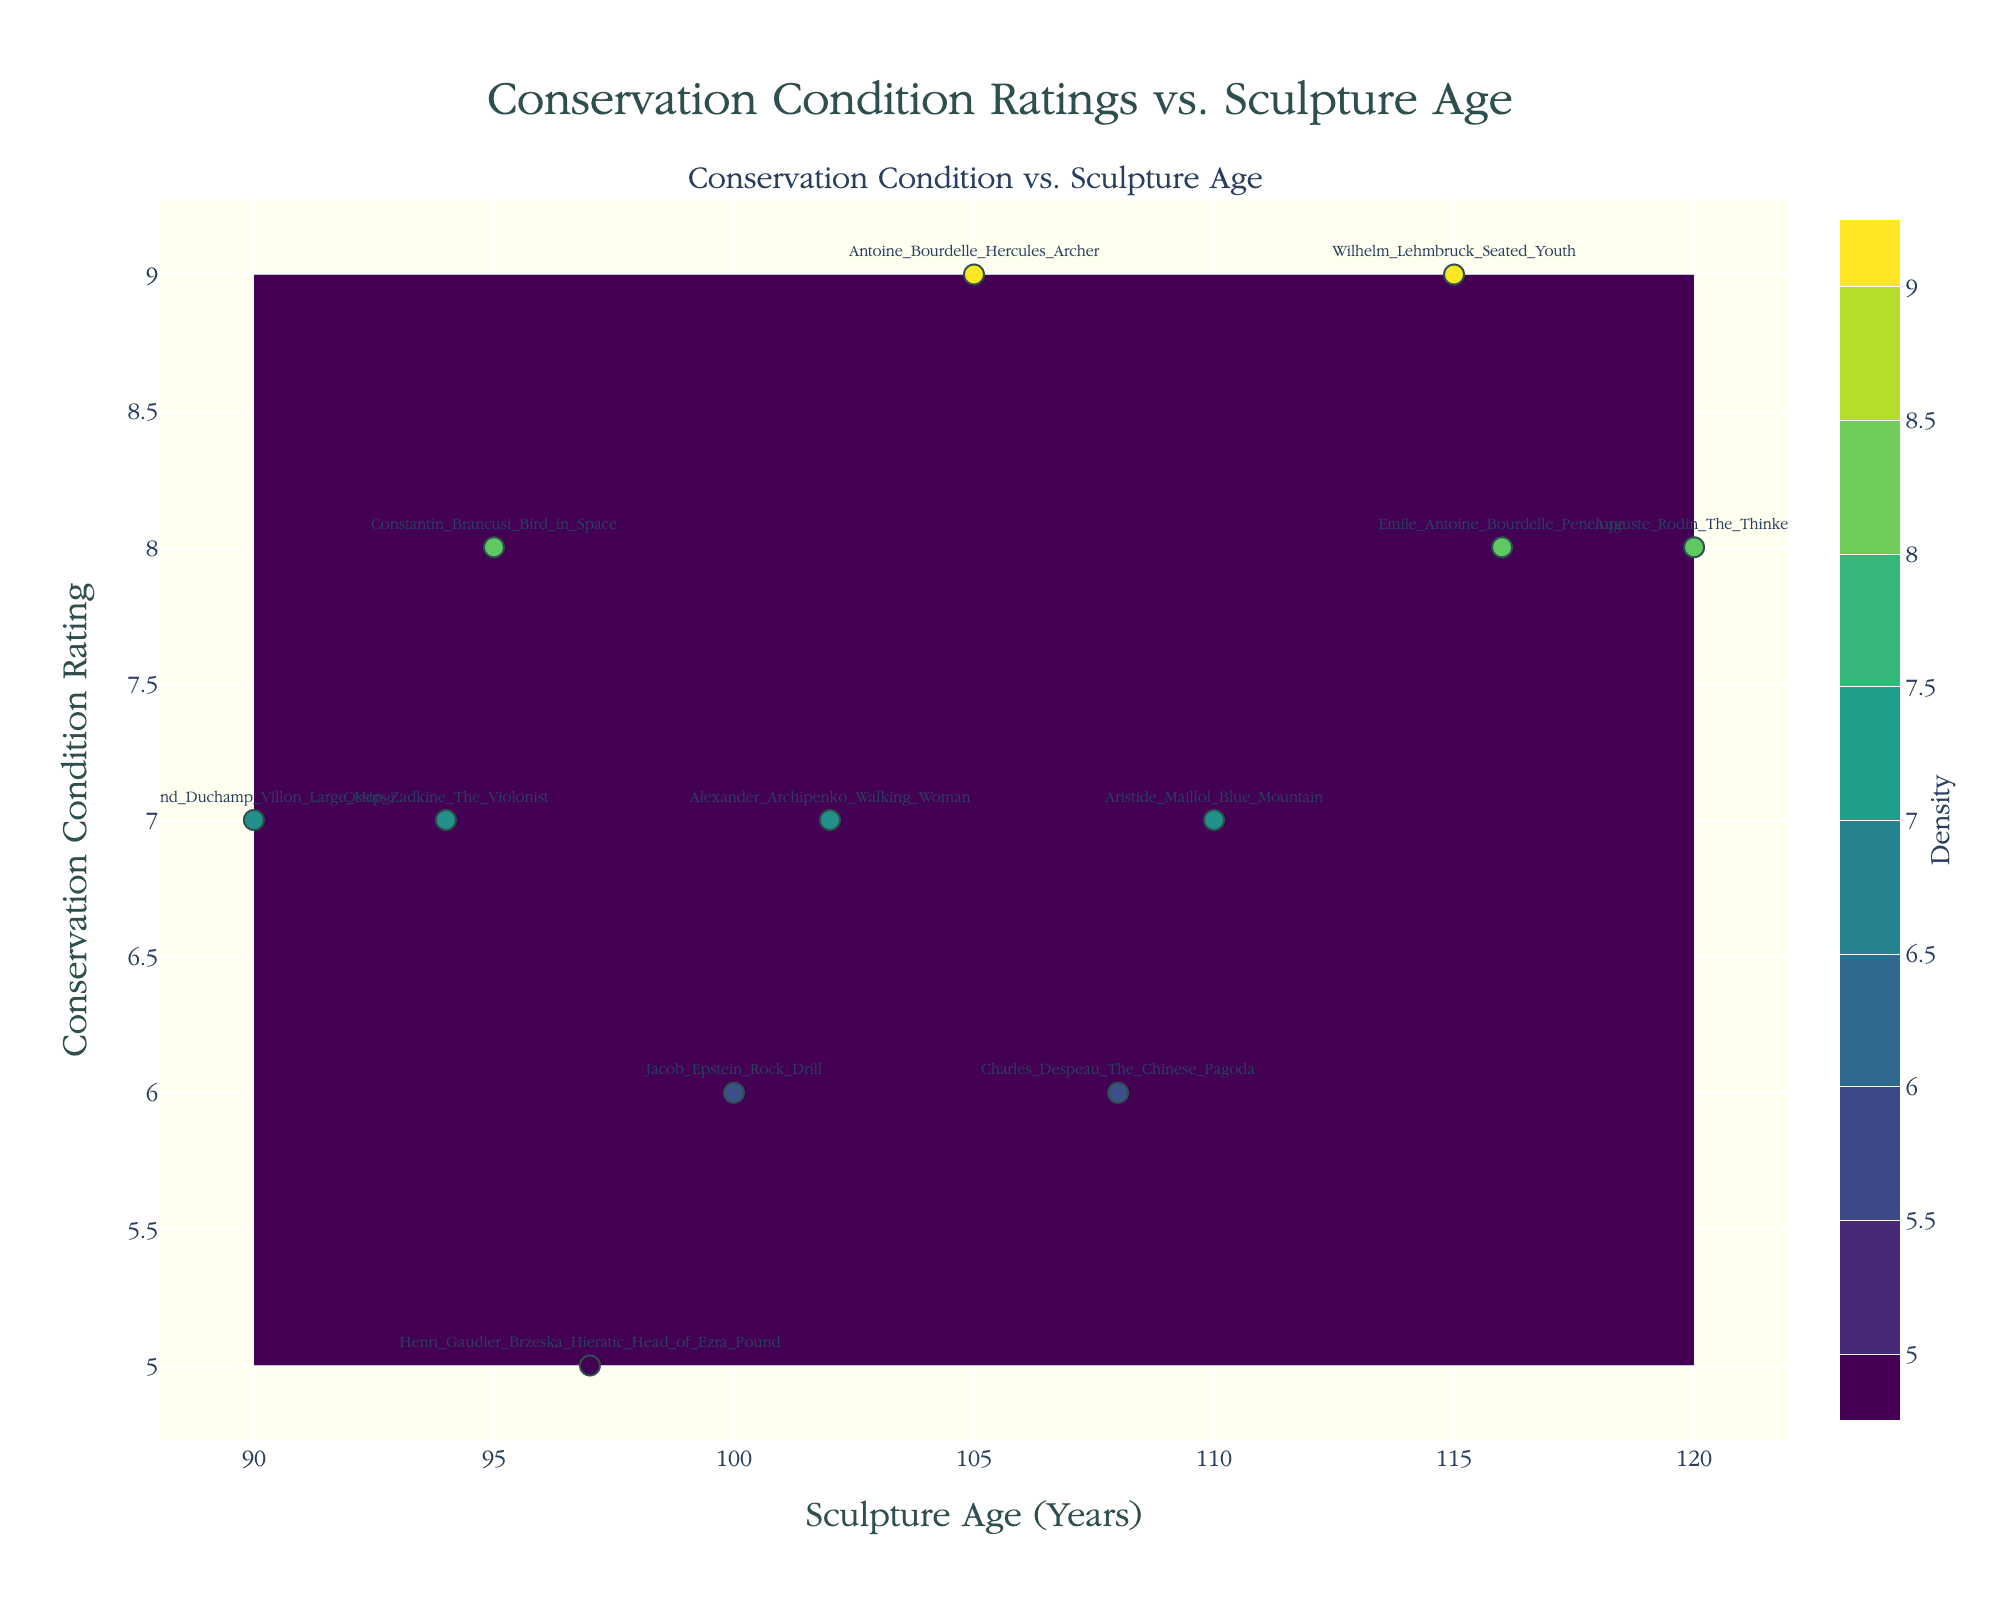What is the title of the figure? The title is displayed at the top center of the figure.
Answer: Conservation Condition Ratings vs. Sculpture Age What is the age range of the sculptures shown in the figure? The age range is indicated by the x-axis that spans from the minimum to the maximum age values of the sculptures. Observing the axis, the age range is from around 90 to 120 years.
Answer: 90 to 120 years Which sculpture has the highest conservation condition rating? The scatter plot includes labels for each sculpture. By identifying the point with the highest y-axis value (conservation condition rating), it is clear that "Antoine_Bourdelle_Hercules_Archer" has the highest rating of 9.
Answer: Antoine Bourdelle Hercules Archer Which sculpture has the lowest conservation condition rating and what is its age? By identifying the point with the lowest y-axis value (conservation condition rating of 5) and checking its label, the sculpture is "Henri Gaudier-Brzeska Hieratic Head of Ezra Pound," with an age of 97 years.
Answer: Henri Gaudier-Brzeska Hieratic Head of Ezra Pound, 97 years How many sculptures have a conservation condition rating of 8? By examining the y-axis and counting the points that line up with the rating of 8, we see that there are three sculptures with this condition rating.
Answer: 3 What's the age difference between the sculptures "Wilhelm Lehmbruck Seated Youth" and "Raymond Duchamp-Villon Large Horse"? Locate both sculptures on the scatter plot, read their respective ages from the x-axis (115 for Wilhelm Lehmbruck Seated Youth and 90 for Raymond Duchamp-Villon Large Horse), and compute the difference: 115 - 90.
Answer: 25 years Which sculpture pairs have approximately the same conservation condition rating but differ in age, and what's the age difference? Identify pairs of sculptures with the same y-axis value but different x-axis values. Compare ages and compute differences. For instance, "Wilhelm Lehmbruck Seated Youth" (rating 9, age 115) and "Antoine Bourdelle Hercules Archer" (rating 9, age 105) differ by 10 years. Similarly, pair "Auguste Rodin The Thinker" (rating 8, age 120) and "Emile Antoine Bourdelle Penelope" (rating 8, age 116) differ by 4 years.
Answer: Wilhelm Lehmbruck Seated Youth and Antoine Bourdelle Hercules Archer, 10 years; Auguste Rodin The Thinker and Emile Antoine Bourdelle Penelope, 4 years What can you infer about the relationship between sculpture age and conservation condition ratings based on the contour density? The density of the contours provides an indication of the relationship. In zones of high contour density, many sculptures share similar ratings and ages. Lower density might show less common age-rating combinations. Analyzing the contours can help deduce if older sculptures generally have better or worse conservation ratings.
Answer: Density hints at common age-rating patterns What is the approximate age of the sculpture "Alexander Archipenko Walking Woman," and what is its conservation condition rating? Locate the labeled point for "Alexander Archipenko Walking Woman" on the scatter plot. Its position on both axes indicates an age of about 102 years and a conservation condition rating of 7.
Answer: 102 years, rating 7 